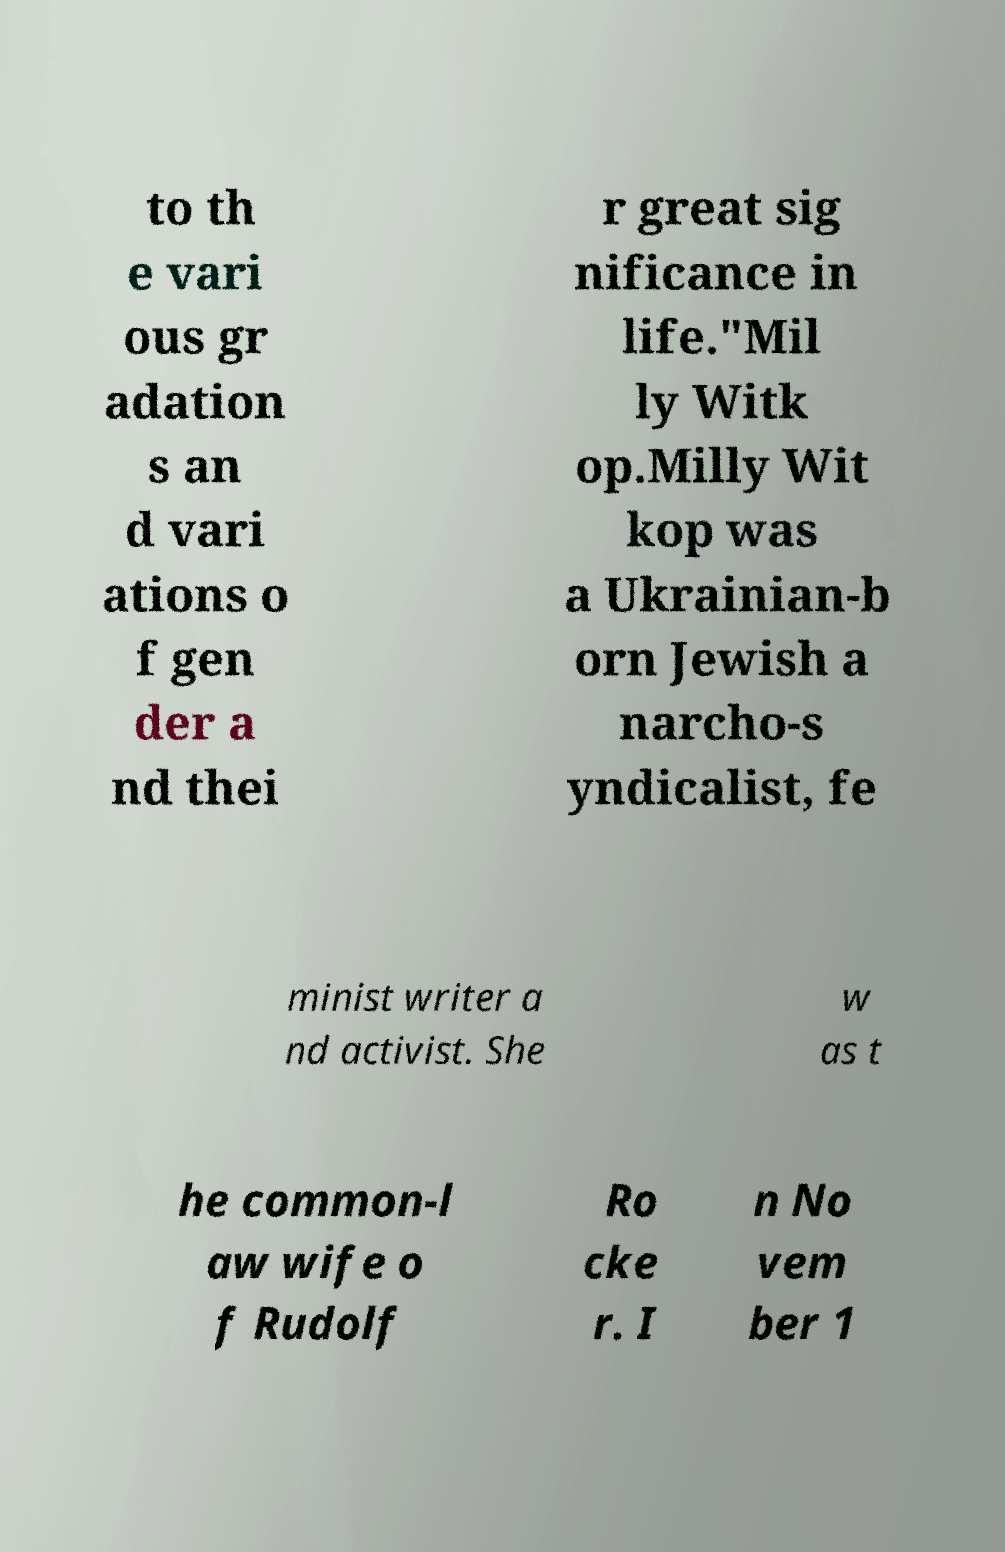Could you extract and type out the text from this image? to th e vari ous gr adation s an d vari ations o f gen der a nd thei r great sig nificance in life."Mil ly Witk op.Milly Wit kop was a Ukrainian-b orn Jewish a narcho-s yndicalist, fe minist writer a nd activist. She w as t he common-l aw wife o f Rudolf Ro cke r. I n No vem ber 1 